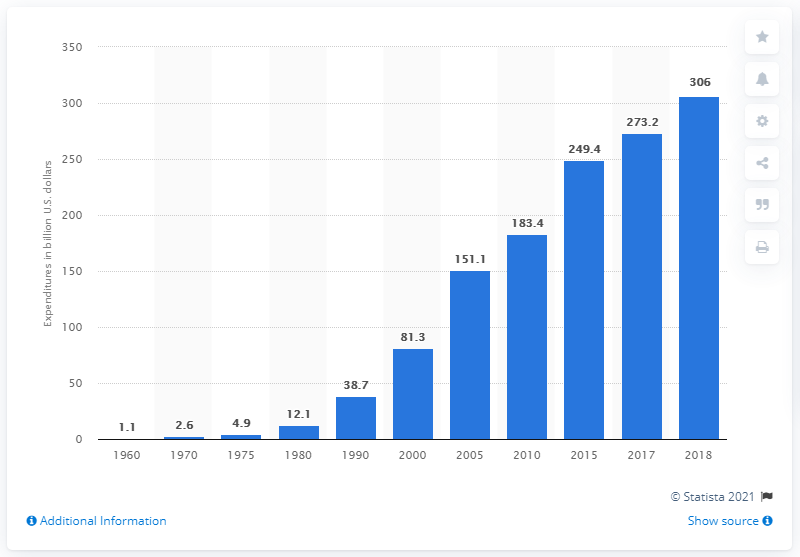Highlight a few significant elements in this photo. The net cost of private health insurance 18 years later was approximately 306. The net cost of private health insurance in the year 2000 was 81.3. 